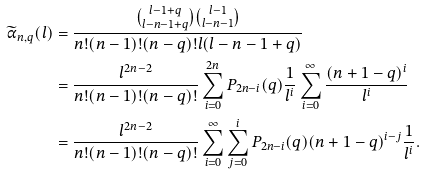Convert formula to latex. <formula><loc_0><loc_0><loc_500><loc_500>\widetilde { \alpha } _ { n , q } ( l ) & = \frac { \binom { l - 1 + q } { l - n - 1 + q } \binom { l - 1 } { l - n - 1 } } { n ! ( n - 1 ) ! ( n - q ) ! l ( l - n - 1 + q ) } \\ & = \frac { l ^ { 2 n - 2 } } { n ! ( n - 1 ) ! ( n - q ) ! } \sum _ { i = 0 } ^ { 2 n } P _ { 2 n - i } ( q ) \frac { 1 } { l ^ { i } } \sum _ { i = 0 } ^ { \infty } \frac { ( n + 1 - q ) ^ { i } } { l ^ { i } } \\ & = \frac { l ^ { 2 n - 2 } } { n ! ( n - 1 ) ! ( n - q ) ! } \sum _ { i = 0 } ^ { \infty } \sum _ { j = 0 } ^ { i } P _ { 2 n - i } ( q ) ( n + 1 - q ) ^ { i - j } \frac { 1 } { l ^ { i } } .</formula> 